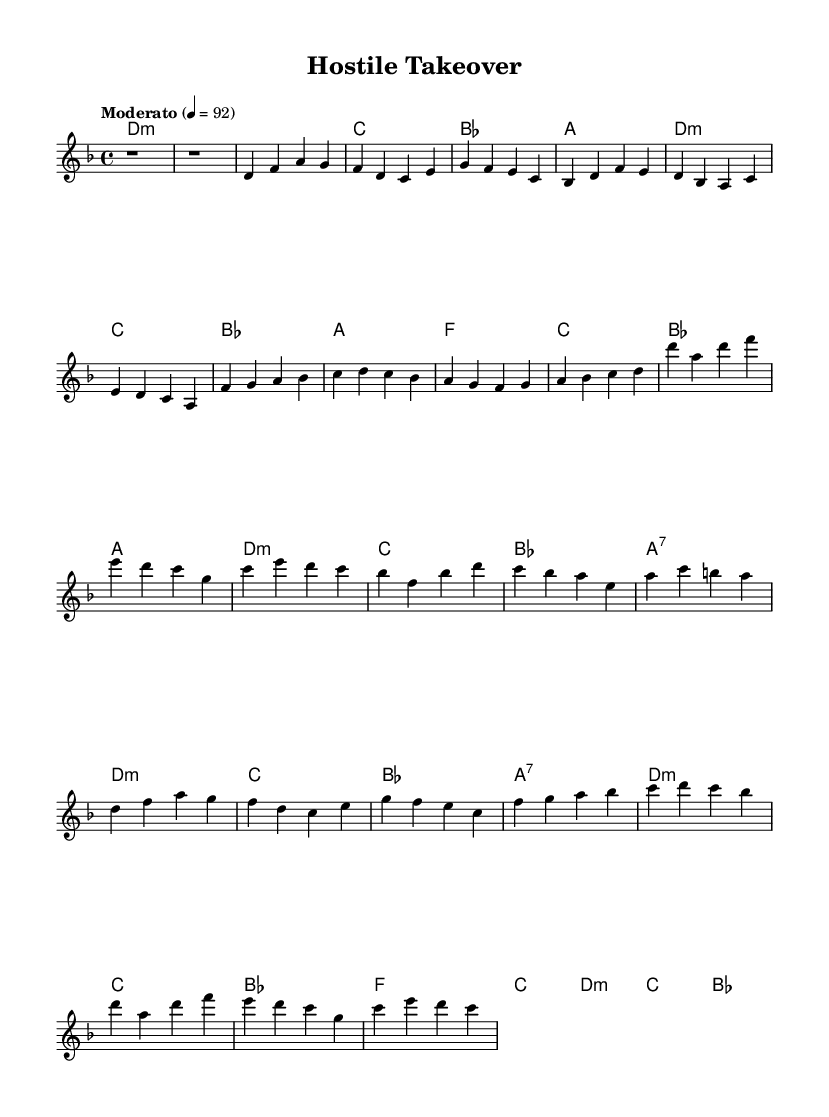What is the key signature of this music? The key signature is D minor, which contains one flat (B flat). The signature is indicated at the beginning, next to the clef.
Answer: D minor What is the time signature of this music? The time signature is located at the beginning of the sheet music, indicated as 4/4. This means there are four beats in each measure, and the quarter note gets one beat.
Answer: 4/4 What is the tempo marking for this piece? The tempo marking is found at the beginning of the score, given as "Moderato" with a metronome marking of 4 = 92, indicating a moderate speed.
Answer: Moderato How many measures are there in the chorus section? To determine this, locate the chorus section which is indicated by the repeated melodic lines. Counting the measures gives a total of four distinct measures in the chorus.
Answer: 4 What type of chord follows the A major chord in the chorus? The chord progression in the chorus section can be analyzed, and the A7 chord follows directly after A major. A7 is a dominant seventh chord that adds tension before resolving.
Answer: A7 Which section of the song is abbreviated? The sheet music indicates that the second verse, pre-chorus, and final chorus are abbreviated, meaning they are shortened from their original versions. This is marked in the respective sections of the score.
Answer: Second verse, pre-chorus, final chorus What is the harmonic structure used in the pre-chorus? The pre-chorus contains a harmonic progression featuring a change from F major to C major and then to B flat major, demonstrating a common structure used to build tension leading into the chorus.
Answer: F, C, B flat 